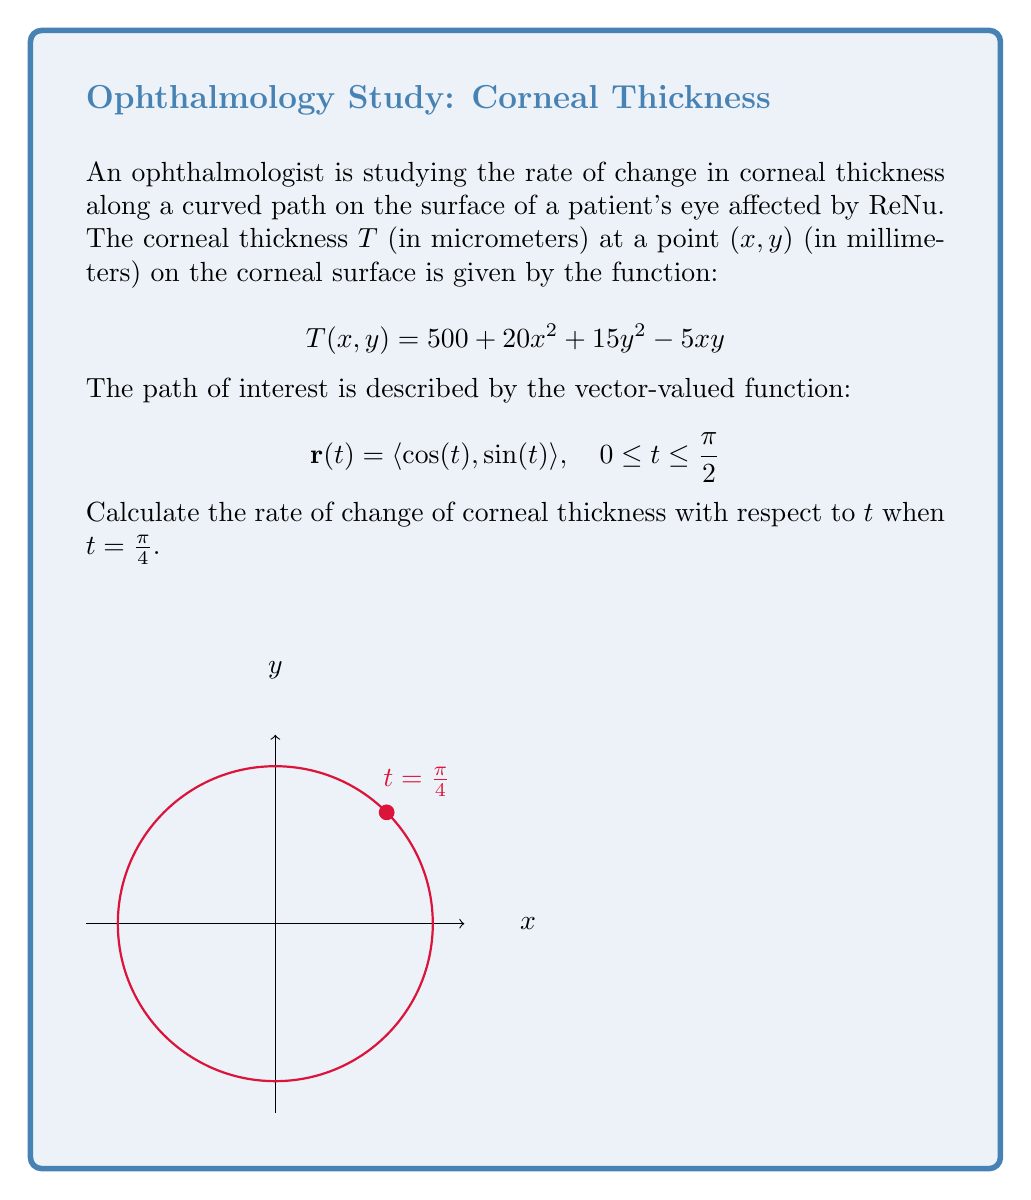Give your solution to this math problem. To solve this problem, we'll use the chain rule for vector-valued functions. The steps are as follows:

1) First, we need to find $\frac{\partial T}{\partial x}$ and $\frac{\partial T}{\partial y}$:

   $$\frac{\partial T}{\partial x} = 40x - 5y$$
   $$\frac{\partial T}{\partial y} = 30y - 5x$$

2) Next, we need to find $\frac{dx}{dt}$ and $\frac{dy}{dt}$:

   $$\frac{dx}{dt} = -\sin(t)$$
   $$\frac{dy}{dt} = \cos(t)$$

3) Now, we can use the chain rule:

   $$\frac{dT}{dt} = \frac{\partial T}{\partial x} \cdot \frac{dx}{dt} + \frac{\partial T}{\partial y} \cdot \frac{dy}{dt}$$

4) Substituting our expressions:

   $$\frac{dT}{dt} = (40x - 5y)(-\sin(t)) + (30y - 5x)(\cos(t))$$

5) At $t = \frac{\pi}{4}$, we have:

   $$x = \cos(\frac{\pi}{4}) = \frac{\sqrt{2}}{2}$$
   $$y = \sin(\frac{\pi}{4}) = \frac{\sqrt{2}}{2}$$
   $$\sin(\frac{\pi}{4}) = \cos(\frac{\pi}{4}) = \frac{\sqrt{2}}{2}$$

6) Substituting these values:

   $$\frac{dT}{dt} = (40\cdot\frac{\sqrt{2}}{2} - 5\cdot\frac{\sqrt{2}}{2})(-\frac{\sqrt{2}}{2}) + (30\cdot\frac{\sqrt{2}}{2} - 5\cdot\frac{\sqrt{2}}{2})(\frac{\sqrt{2}}{2})$$

7) Simplifying:

   $$\frac{dT}{dt} = -\frac{35}{2} + \frac{25}{2} = -5$$

Therefore, at $t = \frac{\pi}{4}$, the rate of change of corneal thickness is -5 micrometers per radian.
Answer: $-5$ μm/rad 